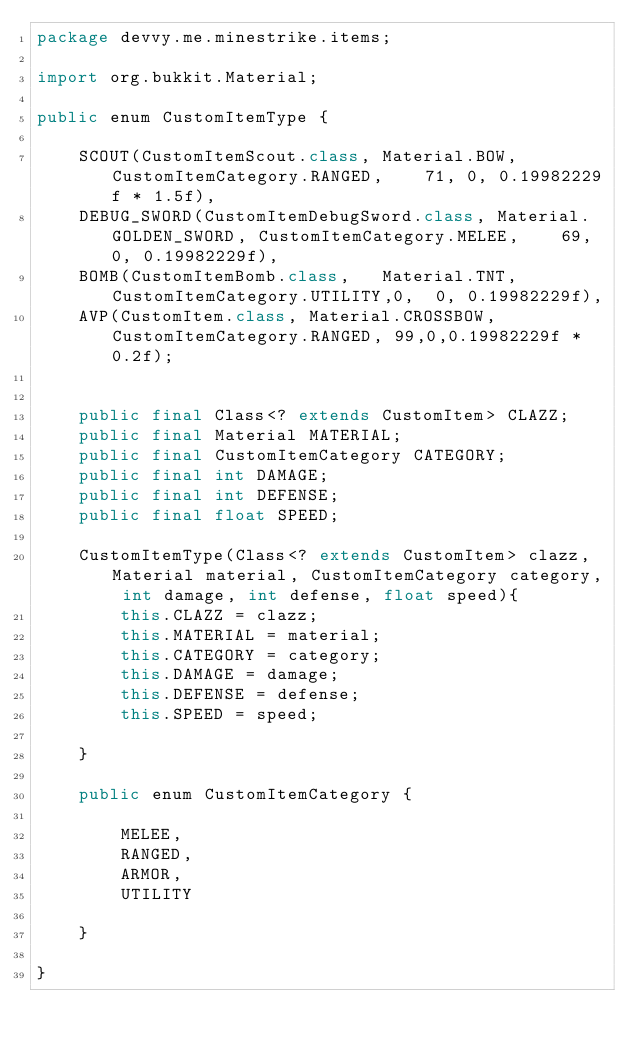Convert code to text. <code><loc_0><loc_0><loc_500><loc_500><_Java_>package devvy.me.minestrike.items;

import org.bukkit.Material;

public enum CustomItemType {

    SCOUT(CustomItemScout.class, Material.BOW, CustomItemCategory.RANGED,    71, 0, 0.19982229f * 1.5f),
    DEBUG_SWORD(CustomItemDebugSword.class, Material.GOLDEN_SWORD, CustomItemCategory.MELEE,    69, 0, 0.19982229f),
    BOMB(CustomItemBomb.class,   Material.TNT, CustomItemCategory.UTILITY,0,  0, 0.19982229f),
    AVP(CustomItem.class, Material.CROSSBOW, CustomItemCategory.RANGED, 99,0,0.19982229f * 0.2f);


    public final Class<? extends CustomItem> CLAZZ;
    public final Material MATERIAL;
    public final CustomItemCategory CATEGORY;
    public final int DAMAGE;
    public final int DEFENSE;
    public final float SPEED;

    CustomItemType(Class<? extends CustomItem> clazz, Material material, CustomItemCategory category, int damage, int defense, float speed){
        this.CLAZZ = clazz;
        this.MATERIAL = material;
        this.CATEGORY = category;
        this.DAMAGE = damage;
        this.DEFENSE = defense;
        this.SPEED = speed;

    }

    public enum CustomItemCategory {

        MELEE,
        RANGED,
        ARMOR,
        UTILITY

    }

}
</code> 